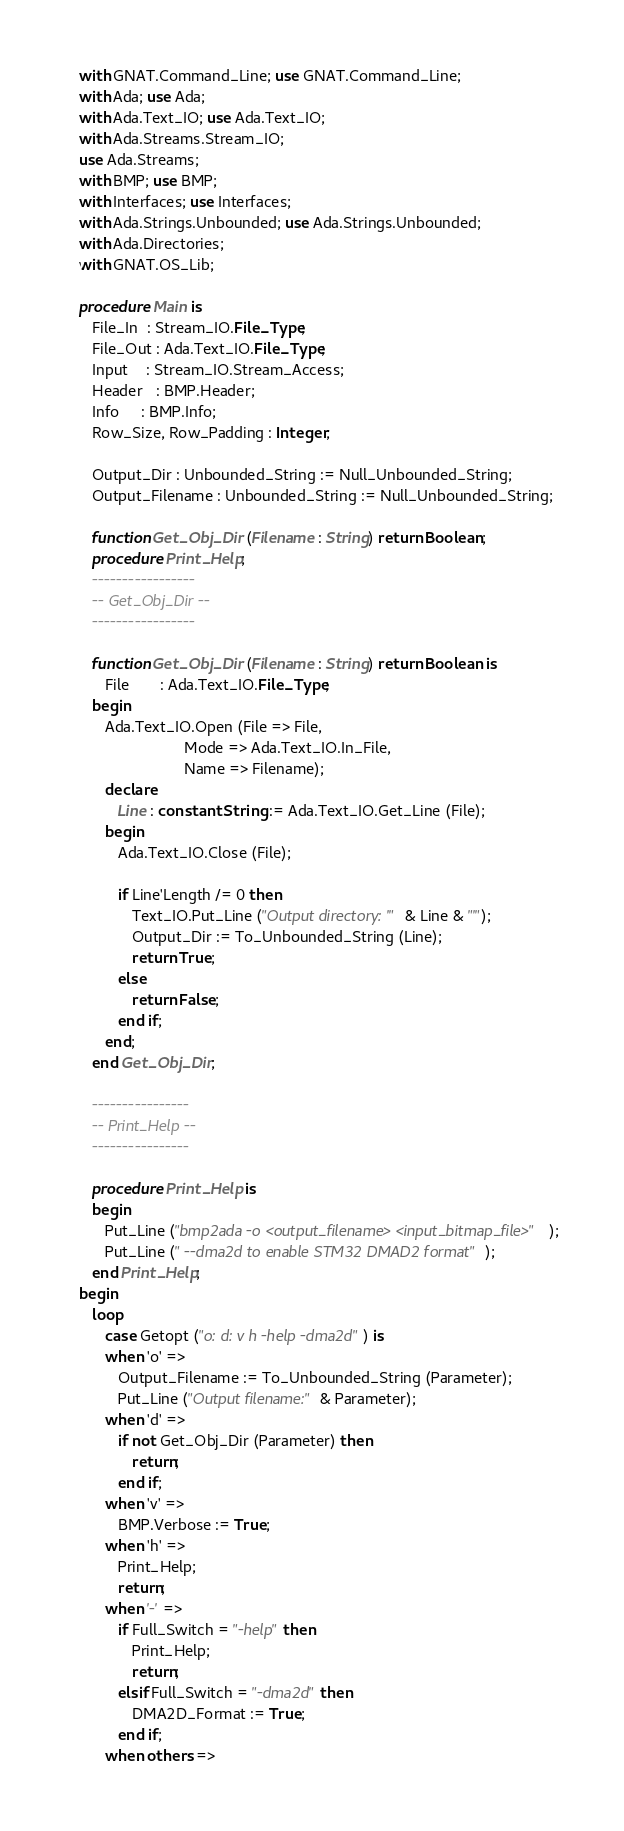Convert code to text. <code><loc_0><loc_0><loc_500><loc_500><_Ada_>with GNAT.Command_Line; use GNAT.Command_Line;
with Ada; use Ada;
with Ada.Text_IO; use Ada.Text_IO;
with Ada.Streams.Stream_IO;
use Ada.Streams;
with BMP; use BMP;
with Interfaces; use Interfaces;
with Ada.Strings.Unbounded; use Ada.Strings.Unbounded;
with Ada.Directories;
with GNAT.OS_Lib;

procedure Main is
   File_In  : Stream_IO.File_Type;
   File_Out : Ada.Text_IO.File_Type;
   Input    : Stream_IO.Stream_Access;
   Header   : BMP.Header;
   Info     : BMP.Info;
   Row_Size, Row_Padding : Integer;

   Output_Dir : Unbounded_String := Null_Unbounded_String;
   Output_Filename : Unbounded_String := Null_Unbounded_String;

   function Get_Obj_Dir (Filename : String) return Boolean;
   procedure Print_Help;
   -----------------
   -- Get_Obj_Dir --
   -----------------

   function Get_Obj_Dir (Filename : String) return Boolean is
      File       : Ada.Text_IO.File_Type;
   begin
      Ada.Text_IO.Open (File => File,
                        Mode => Ada.Text_IO.In_File,
                        Name => Filename);
      declare
         Line : constant String := Ada.Text_IO.Get_Line (File);
      begin
         Ada.Text_IO.Close (File);

         if Line'Length /= 0 then
            Text_IO.Put_Line ("Output directory: '" & Line & "'");
            Output_Dir := To_Unbounded_String (Line);
            return True;
         else
            return False;
         end if;
      end;
   end Get_Obj_Dir;

   ----------------
   -- Print_Help --
   ----------------

   procedure Print_Help is
   begin
      Put_Line ("bmp2ada -o <output_filename> <input_bitmap_file>");
      Put_Line (" --dma2d to enable STM32 DMAD2 format");
   end Print_Help;
begin
   loop
      case Getopt ("o: d: v h -help -dma2d") is
      when 'o' =>
         Output_Filename := To_Unbounded_String (Parameter);
         Put_Line ("Output filename:" & Parameter);
      when 'd' =>
         if not Get_Obj_Dir (Parameter) then
            return;
         end if;
      when 'v' =>
         BMP.Verbose := True;
      when 'h' =>
         Print_Help;
         return;
      when '-' =>
         if Full_Switch = "-help" then
            Print_Help;
            return;
         elsif Full_Switch = "-dma2d" then
            DMA2D_Format := True;
         end if;
      when others =></code> 